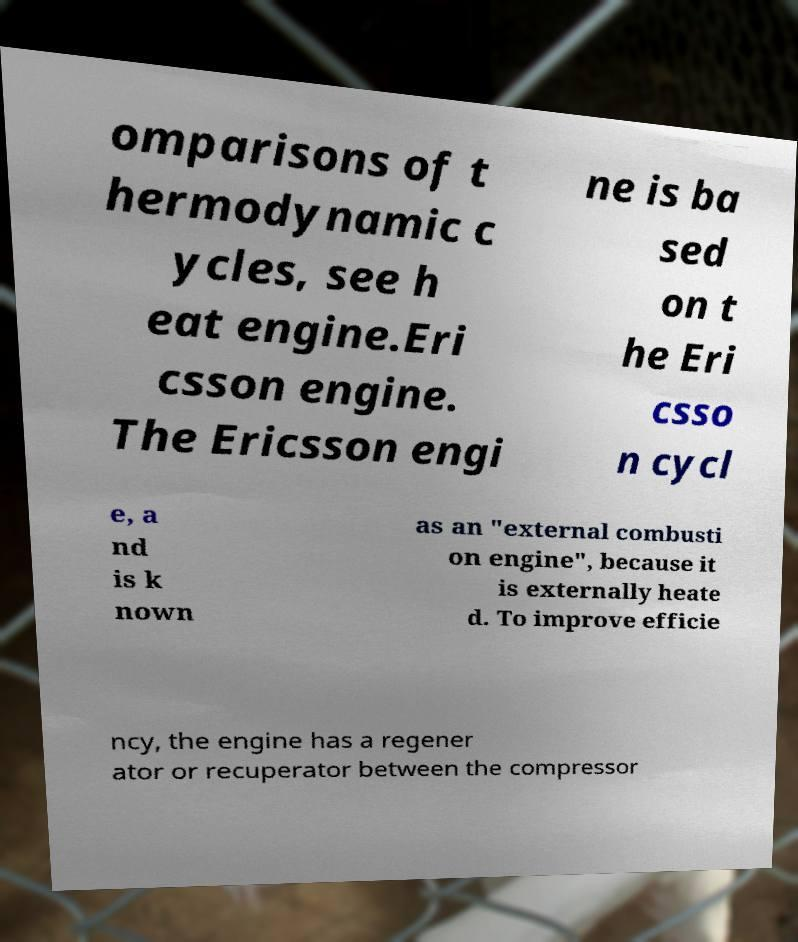Please read and relay the text visible in this image. What does it say? omparisons of t hermodynamic c ycles, see h eat engine.Eri csson engine. The Ericsson engi ne is ba sed on t he Eri csso n cycl e, a nd is k nown as an "external combusti on engine", because it is externally heate d. To improve efficie ncy, the engine has a regener ator or recuperator between the compressor 